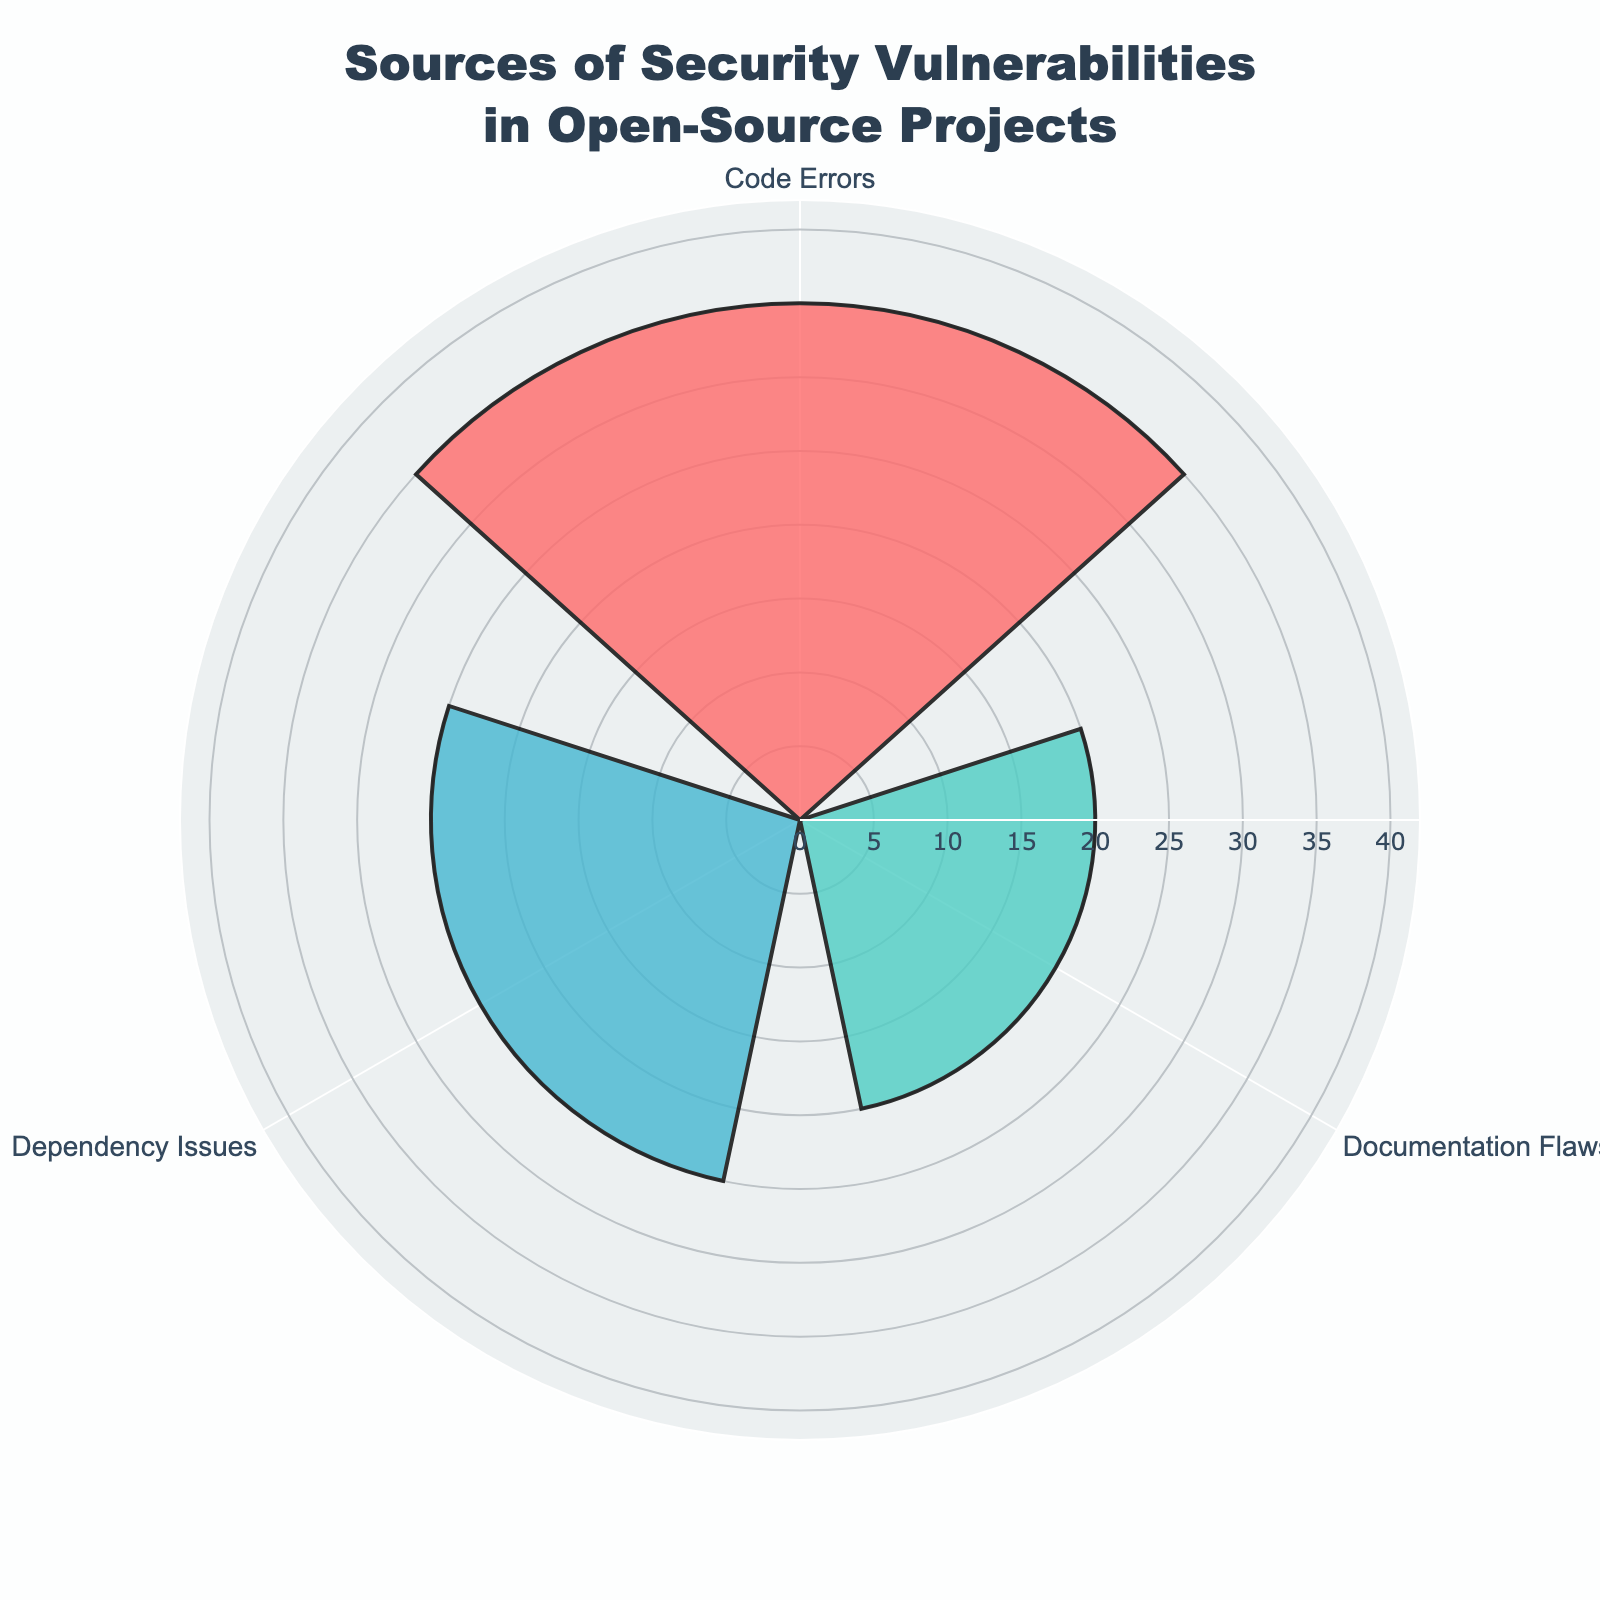what is the title of the figure? The title is at the top of the figure. It reads "Sources of Security Vulnerabilities in Open-Source Projects".
Answer: Sources of Security Vulnerabilities in Open-Source Projects What category has the highest number of vulnerabilities? By looking at the lengths of the bars (spokes) in the rose chart, the category with the longest bar is "Code Errors".
Answer: Code Errors How many total vulnerabilities are there? Sum the values from all categories: 35 (Code Errors) + 20 (Documentation Flaws) + 25 (Dependency Issues) = 80
Answer: 80 What's the average number of vulnerabilities per category? The sum of all values is 80, and there are 3 categories: 80 / 3 = approximately 26.67
Answer: 26.67 Which category has fewer vulnerabilities: Documentation Flaws or Dependency Issues? Compare the lengths of the bars for these two categories. The bar for "Documentation Flaws" is shorter, indicating fewer vulnerabilities.
Answer: Documentation Flaws How much greater is the number of vulnerabilities in Code Errors compared to Dependency Issues? Subtract the number of vulnerabilities in Dependency Issues from those in Code Errors: 35 - 25 = 10
Answer: 10 Which category is represented by the green color? The green bar in the rose chart represents the "Documentation Flaws" category.
Answer: Documentation Flaws What is the difference between the number of vulnerabilities in the category with the most and the category with the fewest vulnerabilities? The category with the most vulnerabilities is Code Errors (35), and the category with the fewest is Documentation Flaws (20). The difference is 35 - 20 = 15
Answer: 15 What percentage of total vulnerabilities does the Dependency Issues category account for? First, find the total number of vulnerabilities, which is 80. Then, calculate the percentage for Dependency Issues: (25 / 80) * 100 = 31.25%
Answer: 31.25% Which axis shows the categories, and which shows the number of vulnerabilities? The angular axis (around the circle) shows the categories, while the radial axis (from the center to the edge) shows the number of vulnerabilities.
Answer: Angular axis: categories; Radial axis: number of vulnerabilities 